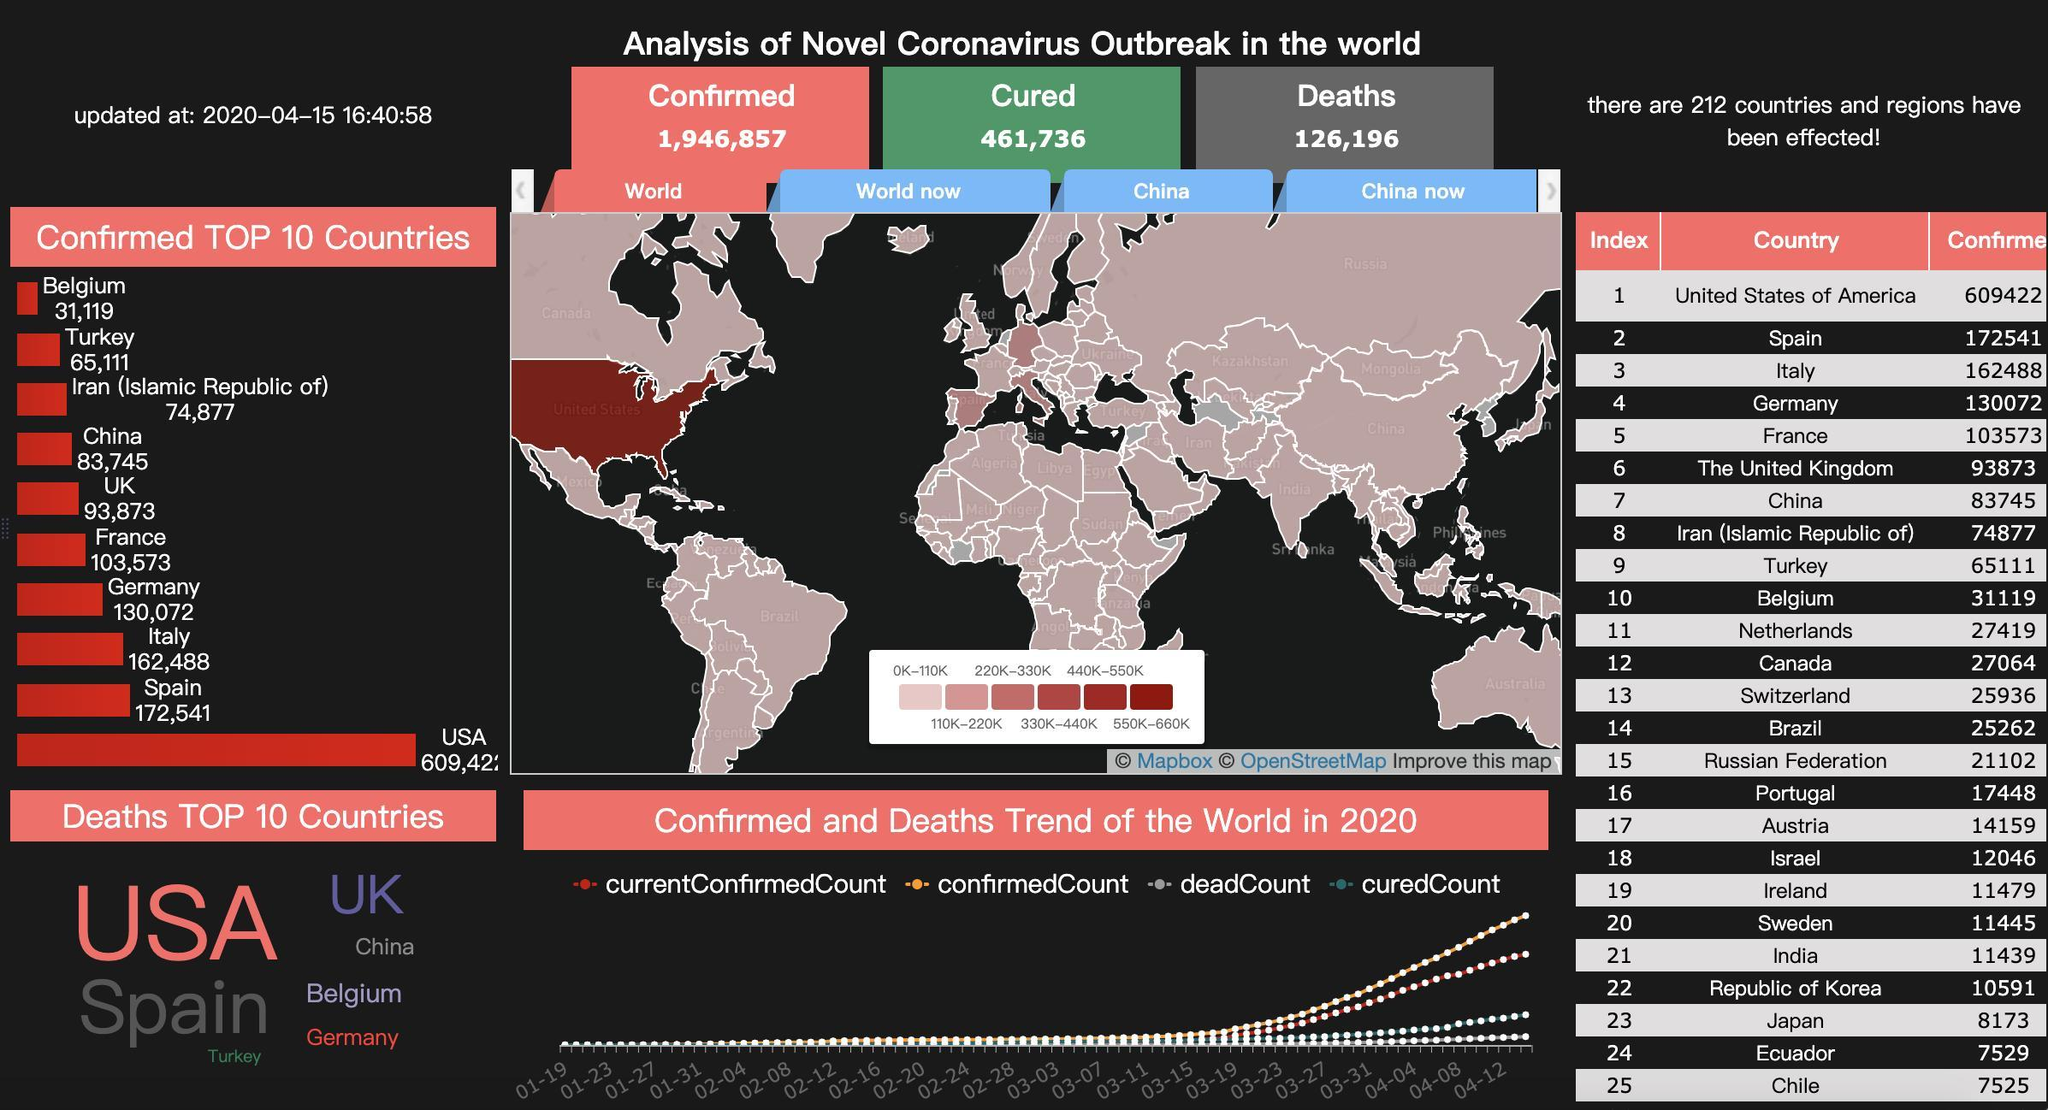What is the total number of deaths in the South American countries?
Answer the question with a short phrase. 40316 Among the 25 countries name the countries where number of deaths is less than 10000. Japan, Ecuador, Chile Which country suffered the most fatality due to coronavirus? USA Name the South American countries given in the list of 25 countries. Brazil, Ecuador, Chile What is the total number of deaths in Italy and Spain taken together? 335029 